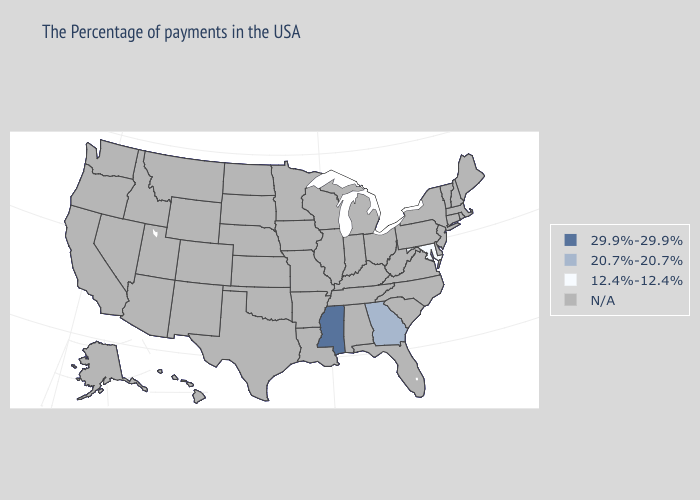What is the value of West Virginia?
Short answer required. N/A. Does the first symbol in the legend represent the smallest category?
Concise answer only. No. Does Maryland have the highest value in the USA?
Short answer required. No. Among the states that border Tennessee , which have the highest value?
Write a very short answer. Mississippi. How many symbols are there in the legend?
Concise answer only. 4. What is the value of New York?
Quick response, please. N/A. Name the states that have a value in the range 29.9%-29.9%?
Write a very short answer. Mississippi. Does Georgia have the lowest value in the USA?
Keep it brief. No. What is the value of Minnesota?
Write a very short answer. N/A. What is the lowest value in the USA?
Give a very brief answer. 12.4%-12.4%. 